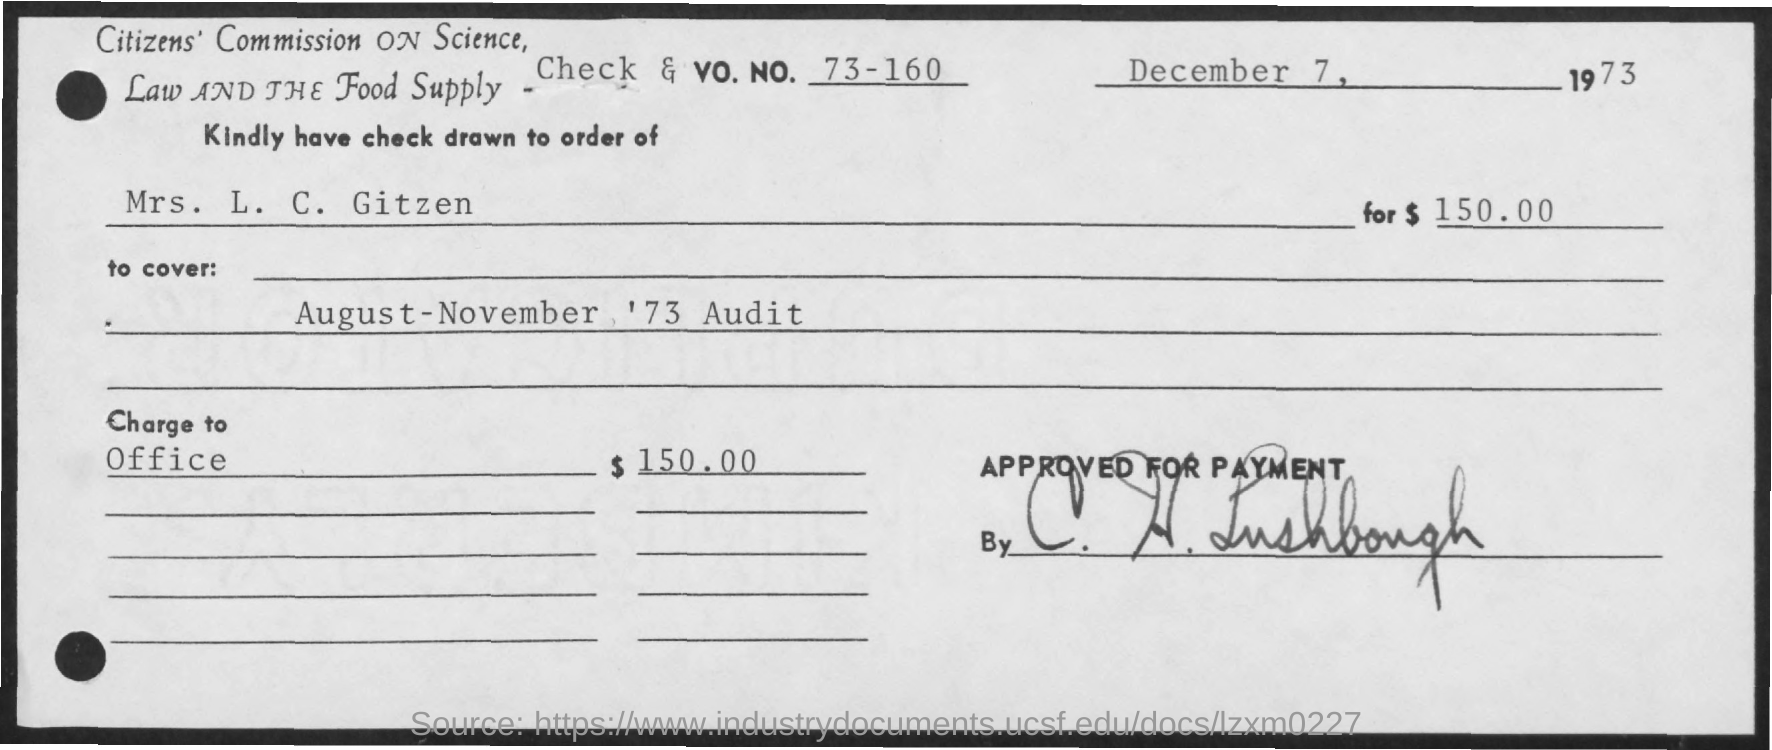What is the date mentioned in the given page ?
Offer a terse response. DECEMBER 7, 1973. What is the check & vo.no. mentioned ?
Your answer should be very brief. 73-160. What is the name mentioned at the check drawn to order of?
Keep it short and to the point. Mrs. L .C. Gitzen. What is the amount mentioned ?
Provide a succinct answer. $150.00. 